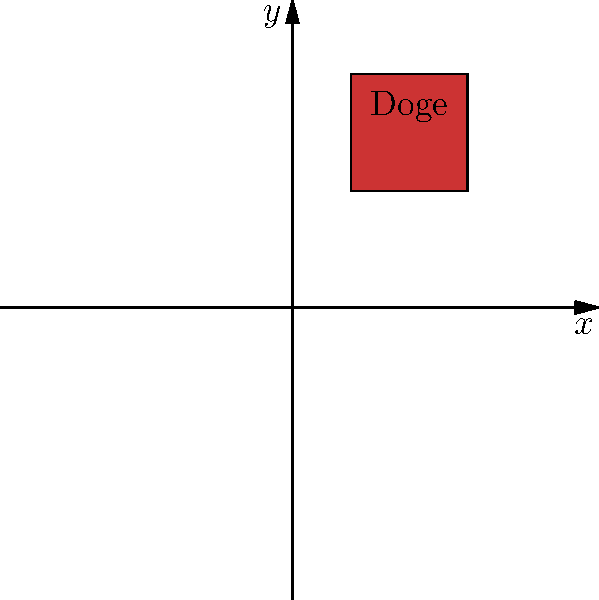Yo, check out this Cartesian plane. There's a meme character "Doge" chilling somewhere. What are its coordinates? Like, whatever. Alright, let's break this down:

1. The Cartesian plane is divided into four quadrants by the x and y axes.
2. The red square represents the meme character "Doge".
3. To find the coordinates, we need to locate the center of the square:
   - The square's left edge is at $x=1$ and right edge at $x=3$
   - The square's bottom edge is at $y=2$ and top edge at $y=4$
4. The center of the square (where the dot is) would be:
   - x-coordinate: $(1+3)/2 = 2$
   - y-coordinate: $(2+4)/2 = 3$
5. Therefore, the coordinates of "Doge" are $(2,3)$.

That's it. No big deal.
Answer: $(2,3)$ 